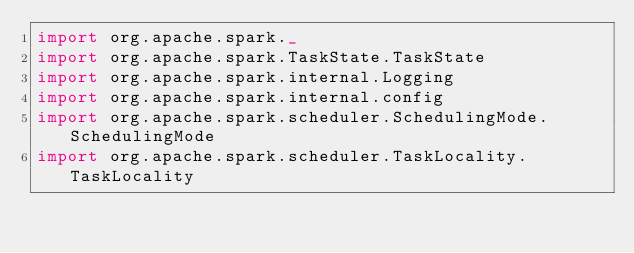<code> <loc_0><loc_0><loc_500><loc_500><_Scala_>import org.apache.spark._
import org.apache.spark.TaskState.TaskState
import org.apache.spark.internal.Logging
import org.apache.spark.internal.config
import org.apache.spark.scheduler.SchedulingMode.SchedulingMode
import org.apache.spark.scheduler.TaskLocality.TaskLocality</code> 